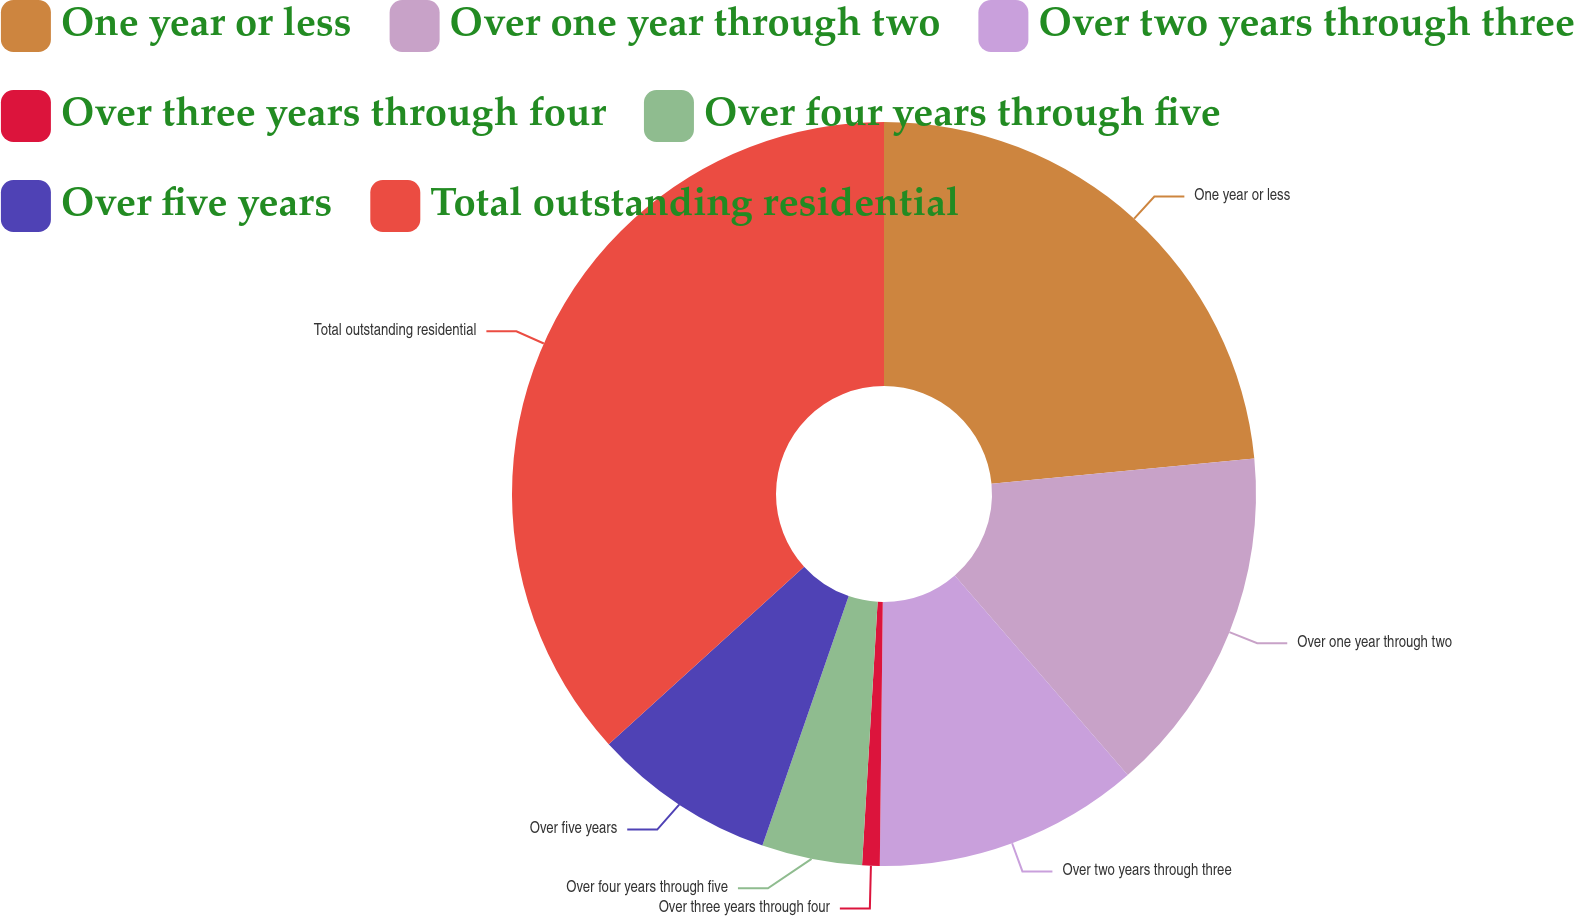<chart> <loc_0><loc_0><loc_500><loc_500><pie_chart><fcel>One year or less<fcel>Over one year through two<fcel>Over two years through three<fcel>Over three years through four<fcel>Over four years through five<fcel>Over five years<fcel>Total outstanding residential<nl><fcel>23.48%<fcel>15.15%<fcel>11.55%<fcel>0.76%<fcel>4.36%<fcel>7.96%<fcel>36.74%<nl></chart> 